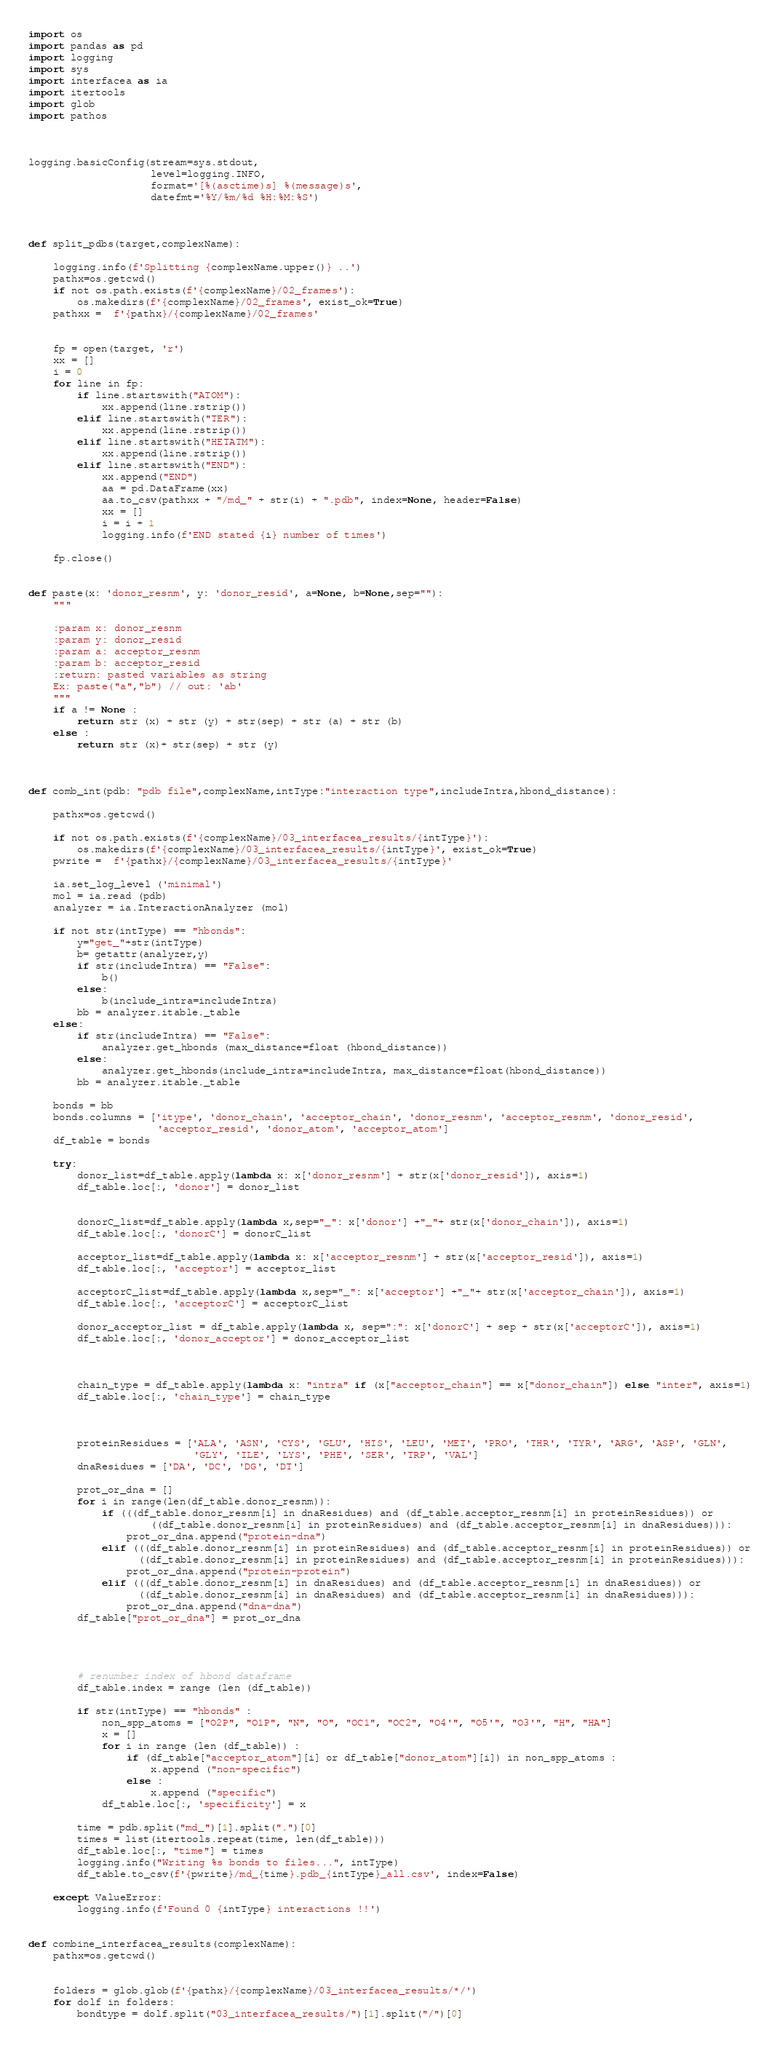Convert code to text. <code><loc_0><loc_0><loc_500><loc_500><_Python_>import os
import pandas as pd
import logging
import sys
import interfacea as ia
import itertools
import glob
import pathos



logging.basicConfig(stream=sys.stdout,
                    level=logging.INFO,
                    format='[%(asctime)s] %(message)s',
                    datefmt='%Y/%m/%d %H:%M:%S')



def split_pdbs(target,complexName):

    logging.info(f'Splitting {complexName.upper()} ..')
    pathx=os.getcwd()
    if not os.path.exists(f'{complexName}/02_frames'):
        os.makedirs(f'{complexName}/02_frames', exist_ok=True)
    pathxx =  f'{pathx}/{complexName}/02_frames'


    fp = open(target, 'r')
    xx = []
    i = 0
    for line in fp:
        if line.startswith("ATOM"):
            xx.append(line.rstrip())
        elif line.startswith("TER"):
            xx.append(line.rstrip())
        elif line.startswith("HETATM"):
            xx.append(line.rstrip())
        elif line.startswith("END"):
            xx.append("END")
            aa = pd.DataFrame(xx)
            aa.to_csv(pathxx + "/md_" + str(i) + ".pdb", index=None, header=False)
            xx = []
            i = i + 1
            logging.info(f'END stated {i} number of times')

    fp.close()


def paste(x: 'donor_resnm', y: 'donor_resid', a=None, b=None,sep=""):
    """

    :param x: donor_resnm
    :param y: donor_resid
    :param a: acceptor_resnm
    :param b: acceptor_resid
    :return: pasted variables as string
    Ex: paste("a","b") // out: 'ab'
    """
    if a != None :
        return str (x) + str (y) + str(sep) + str (a) + str (b)
    else :
        return str (x)+ str(sep) + str (y)



def comb_int(pdb: "pdb file",complexName,intType:"interaction type",includeIntra,hbond_distance):

    pathx=os.getcwd()

    if not os.path.exists(f'{complexName}/03_interfacea_results/{intType}'):
        os.makedirs(f'{complexName}/03_interfacea_results/{intType}', exist_ok=True)
    pwrite =  f'{pathx}/{complexName}/03_interfacea_results/{intType}'

    ia.set_log_level ('minimal')
    mol = ia.read (pdb)
    analyzer = ia.InteractionAnalyzer (mol)

    if not str(intType) == "hbonds":
        y="get_"+str(intType)
        b= getattr(analyzer,y)
        if str(includeIntra) == "False":
            b()
        else:
            b(include_intra=includeIntra)
        bb = analyzer.itable._table
    else:
        if str(includeIntra) == "False":
            analyzer.get_hbonds (max_distance=float (hbond_distance))
        else:
            analyzer.get_hbonds(include_intra=includeIntra, max_distance=float(hbond_distance))
        bb = analyzer.itable._table

    bonds = bb
    bonds.columns = ['itype', 'donor_chain', 'acceptor_chain', 'donor_resnm', 'acceptor_resnm', 'donor_resid',
                     'acceptor_resid', 'donor_atom', 'acceptor_atom']
    df_table = bonds

    try:
        donor_list=df_table.apply(lambda x: x['donor_resnm'] + str(x['donor_resid']), axis=1)
        df_table.loc[:, 'donor'] = donor_list


        donorC_list=df_table.apply(lambda x,sep="_": x['donor'] +"_"+ str(x['donor_chain']), axis=1)
        df_table.loc[:, 'donorC'] = donorC_list

        acceptor_list=df_table.apply(lambda x: x['acceptor_resnm'] + str(x['acceptor_resid']), axis=1)
        df_table.loc[:, 'acceptor'] = acceptor_list

        acceptorC_list=df_table.apply(lambda x,sep="_": x['acceptor'] +"_"+ str(x['acceptor_chain']), axis=1)
        df_table.loc[:, 'acceptorC'] = acceptorC_list

        donor_acceptor_list = df_table.apply(lambda x, sep=":": x['donorC'] + sep + str(x['acceptorC']), axis=1)
        df_table.loc[:, 'donor_acceptor'] = donor_acceptor_list



        chain_type = df_table.apply(lambda x: "intra" if (x["acceptor_chain"] == x["donor_chain"]) else "inter", axis=1)
        df_table.loc[:, 'chain_type'] = chain_type



        proteinResidues = ['ALA', 'ASN', 'CYS', 'GLU', 'HIS', 'LEU', 'MET', 'PRO', 'THR', 'TYR', 'ARG', 'ASP', 'GLN',
                           'GLY', 'ILE', 'LYS', 'PHE', 'SER', 'TRP', 'VAL']
        dnaResidues = ['DA', 'DC', 'DG', 'DT']

        prot_or_dna = []
        for i in range(len(df_table.donor_resnm)):
            if (((df_table.donor_resnm[i] in dnaResidues) and (df_table.acceptor_resnm[i] in proteinResidues)) or
                    ((df_table.donor_resnm[i] in proteinResidues) and (df_table.acceptor_resnm[i] in dnaResidues))):
                prot_or_dna.append("protein-dna")
            elif (((df_table.donor_resnm[i] in proteinResidues) and (df_table.acceptor_resnm[i] in proteinResidues)) or
                  ((df_table.donor_resnm[i] in proteinResidues) and (df_table.acceptor_resnm[i] in proteinResidues))):
                prot_or_dna.append("protein-protein")
            elif (((df_table.donor_resnm[i] in dnaResidues) and (df_table.acceptor_resnm[i] in dnaResidues)) or
                  ((df_table.donor_resnm[i] in dnaResidues) and (df_table.acceptor_resnm[i] in dnaResidues))):
                prot_or_dna.append("dna-dna")
        df_table["prot_or_dna"] = prot_or_dna




        # renumber index of hbond dataframe
        df_table.index = range (len (df_table))

        if str(intType) == "hbonds" :
            non_spp_atoms = ["O2P", "O1P", "N", "O", "OC1", "OC2", "O4'", "O5'", "O3'", "H", "HA"]
            x = []
            for i in range (len (df_table)) :
                if (df_table["acceptor_atom"][i] or df_table["donor_atom"][i]) in non_spp_atoms :
                    x.append ("non-specific")
                else :
                    x.append ("specific")
            df_table.loc[:, 'specificity'] = x

        time = pdb.split("md_")[1].split(".")[0]
        times = list(itertools.repeat(time, len(df_table)))
        df_table.loc[:, "time"] = times
        logging.info("Writing %s bonds to files...", intType)
        df_table.to_csv(f'{pwrite}/md_{time}.pdb_{intType}_all.csv', index=False)

    except ValueError:
        logging.info(f'Found 0 {intType} interactions !!')


def combine_interfacea_results(complexName):
    pathx=os.getcwd()


    folders = glob.glob(f'{pathx}/{complexName}/03_interfacea_results/*/')
    for dolf in folders:
        bondtype = dolf.split("03_interfacea_results/")[1].split("/")[0]</code> 